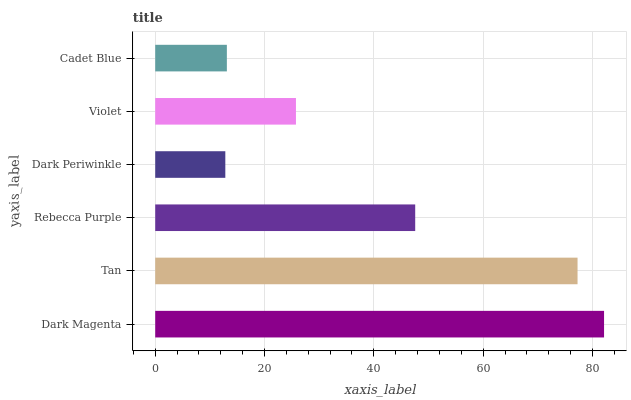Is Dark Periwinkle the minimum?
Answer yes or no. Yes. Is Dark Magenta the maximum?
Answer yes or no. Yes. Is Tan the minimum?
Answer yes or no. No. Is Tan the maximum?
Answer yes or no. No. Is Dark Magenta greater than Tan?
Answer yes or no. Yes. Is Tan less than Dark Magenta?
Answer yes or no. Yes. Is Tan greater than Dark Magenta?
Answer yes or no. No. Is Dark Magenta less than Tan?
Answer yes or no. No. Is Rebecca Purple the high median?
Answer yes or no. Yes. Is Violet the low median?
Answer yes or no. Yes. Is Cadet Blue the high median?
Answer yes or no. No. Is Rebecca Purple the low median?
Answer yes or no. No. 